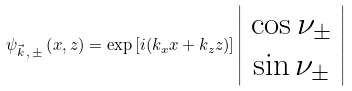Convert formula to latex. <formula><loc_0><loc_0><loc_500><loc_500>\psi _ { \vec { k } \, , \, \pm } \left ( x , z \right ) = \exp \left [ i ( k _ { x } x + k _ { z } z ) \right ] \left | \begin{array} { c } \cos \nu _ { \pm } \\ \sin \nu _ { \pm } \end{array} \right |</formula> 